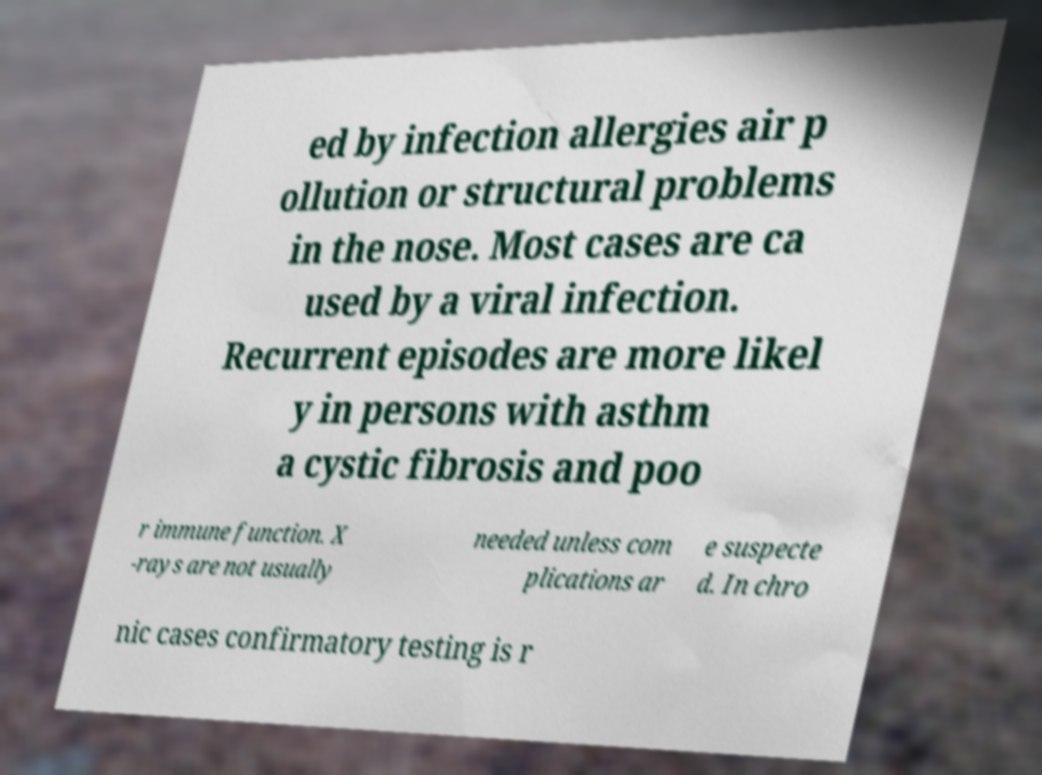Could you assist in decoding the text presented in this image and type it out clearly? ed by infection allergies air p ollution or structural problems in the nose. Most cases are ca used by a viral infection. Recurrent episodes are more likel y in persons with asthm a cystic fibrosis and poo r immune function. X -rays are not usually needed unless com plications ar e suspecte d. In chro nic cases confirmatory testing is r 